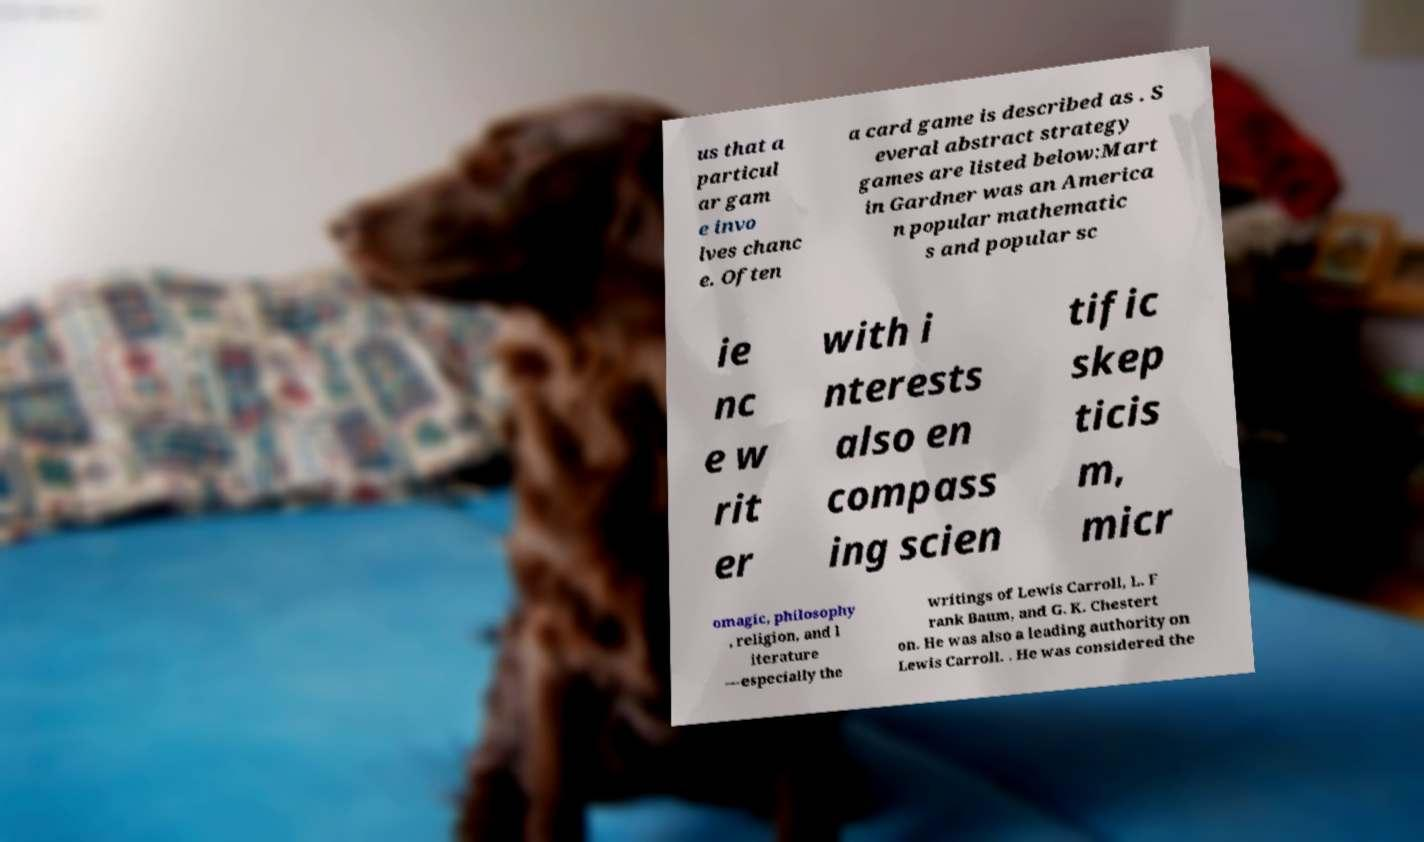There's text embedded in this image that I need extracted. Can you transcribe it verbatim? us that a particul ar gam e invo lves chanc e. Often a card game is described as . S everal abstract strategy games are listed below:Mart in Gardner was an America n popular mathematic s and popular sc ie nc e w rit er with i nterests also en compass ing scien tific skep ticis m, micr omagic, philosophy , religion, and l iterature —especially the writings of Lewis Carroll, L. F rank Baum, and G. K. Chestert on. He was also a leading authority on Lewis Carroll. . He was considered the 